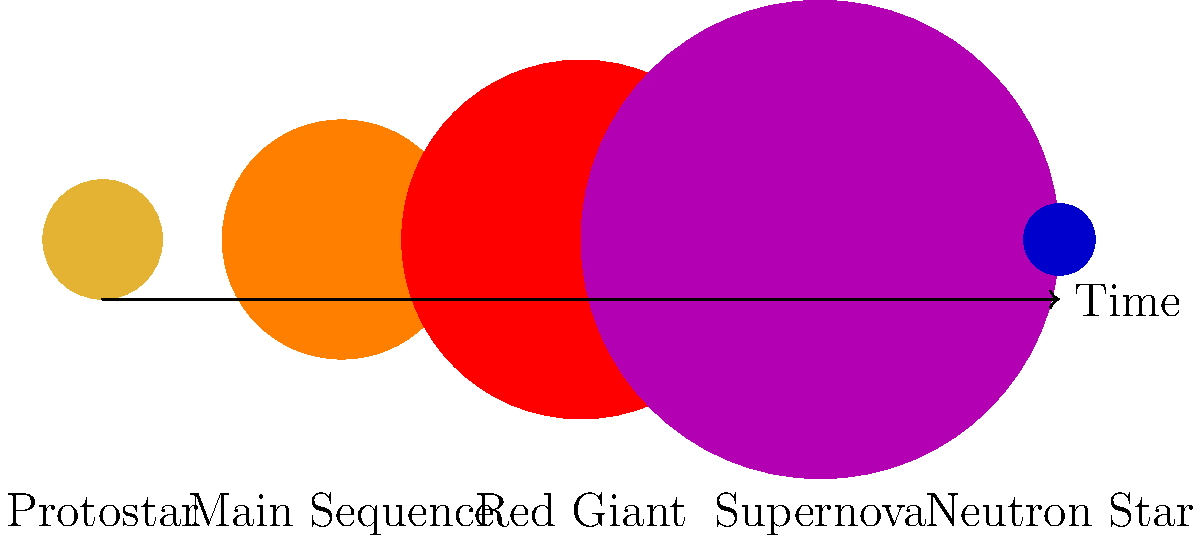In your next vlog about space phenomena, you want to discuss the life cycle of a massive star. Looking at the diagram, which stage represents the most violent and explosive event in a star's life, often resulting in a burst of energy visible across galaxies? Let's break down the life cycle of a massive star as shown in the diagram:

1. Protostar: This is the initial stage where a cloud of gas and dust begins to collapse under its own gravity.

2. Main Sequence: The star spends most of its life in this stage, fusing hydrogen into helium in its core.

3. Red Giant: As the star runs out of hydrogen in its core, it expands and cools, becoming a red giant.

4. Supernova: For massive stars, this is the explosive end of their life. The core collapses while the outer layers are violently ejected into space.

5. Neutron Star: One possible end result of a supernova, where the core of the star collapses into an extremely dense object.

The supernova stage is by far the most violent and explosive event in a star's life. During a supernova:

- The star's core collapses extremely rapidly.
- This collapse triggers a massive explosion.
- The explosion can briefly outshine an entire galaxy.
- Elements heavier than iron are created in this process.
- The energy released is so immense that it's visible across vast distances in the universe.

This makes the supernova the most dramatic and energetic stage in a massive star's life cycle.
Answer: Supernova 